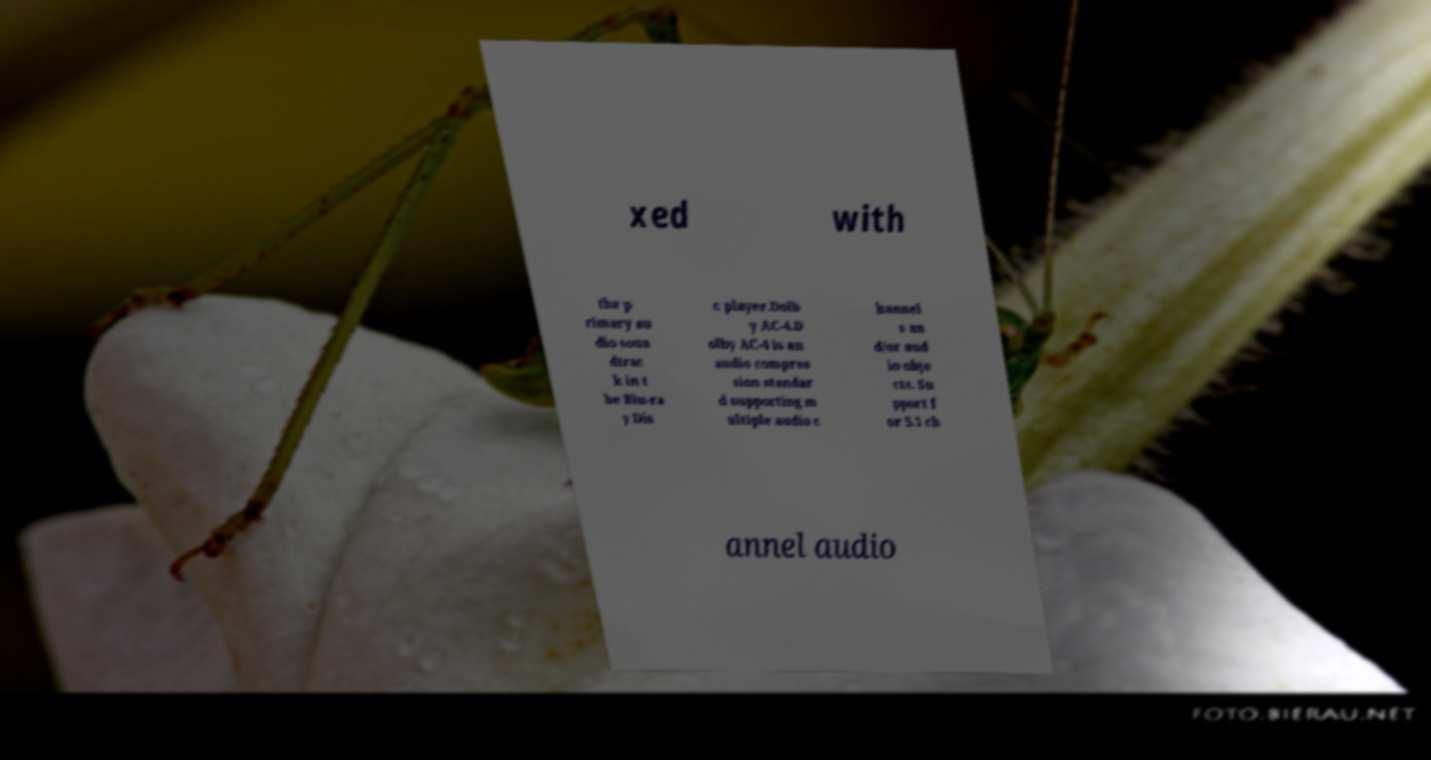For documentation purposes, I need the text within this image transcribed. Could you provide that? xed with the p rimary au dio soun dtrac k in t he Blu-ra y Dis c player.Dolb y AC-4.D olby AC-4 is an audio compres sion standar d supporting m ultiple audio c hannel s an d/or aud io obje cts. Su pport f or 5.1 ch annel audio 